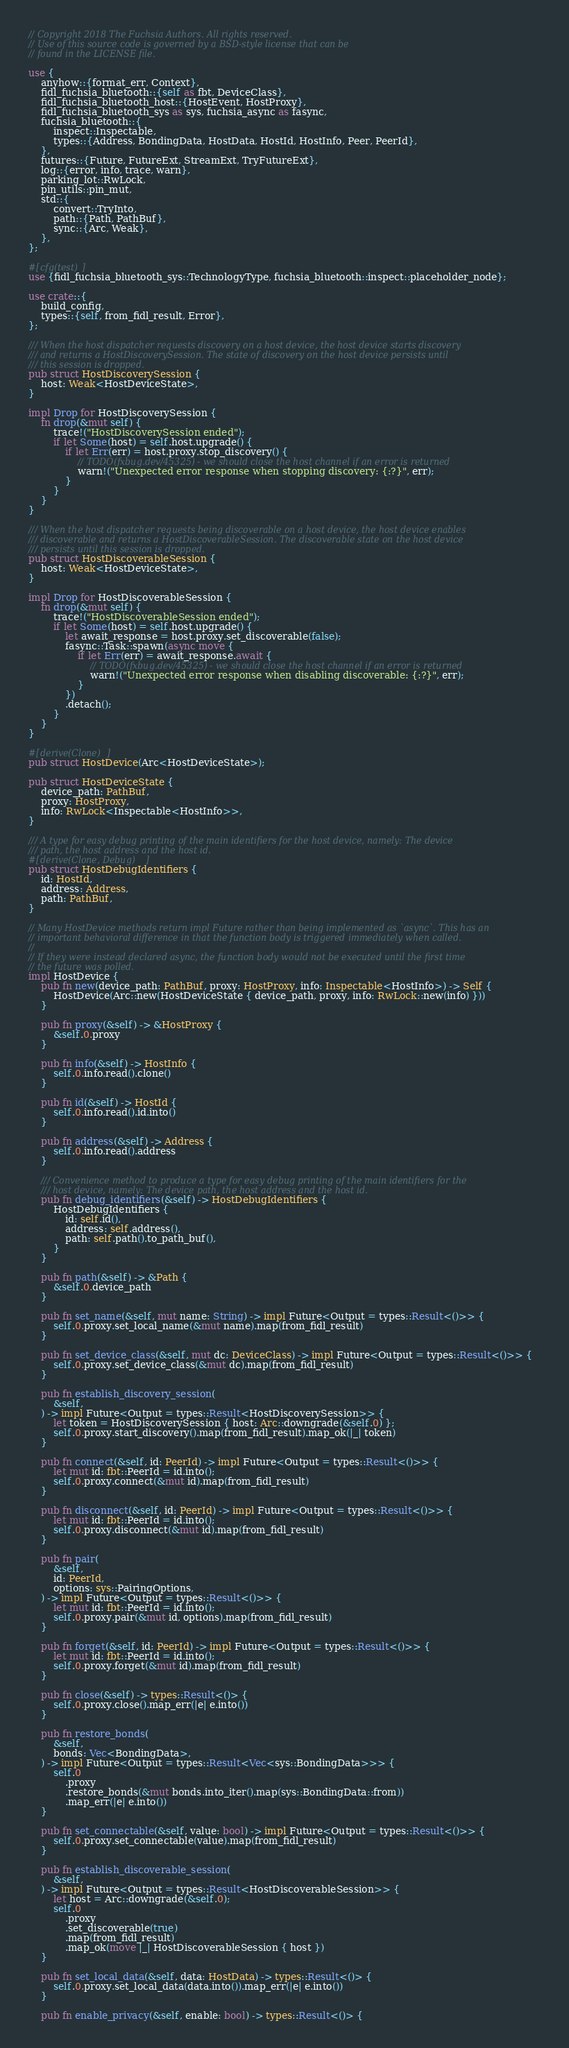Convert code to text. <code><loc_0><loc_0><loc_500><loc_500><_Rust_>// Copyright 2018 The Fuchsia Authors. All rights reserved.
// Use of this source code is governed by a BSD-style license that can be
// found in the LICENSE file.

use {
    anyhow::{format_err, Context},
    fidl_fuchsia_bluetooth::{self as fbt, DeviceClass},
    fidl_fuchsia_bluetooth_host::{HostEvent, HostProxy},
    fidl_fuchsia_bluetooth_sys as sys, fuchsia_async as fasync,
    fuchsia_bluetooth::{
        inspect::Inspectable,
        types::{Address, BondingData, HostData, HostId, HostInfo, Peer, PeerId},
    },
    futures::{Future, FutureExt, StreamExt, TryFutureExt},
    log::{error, info, trace, warn},
    parking_lot::RwLock,
    pin_utils::pin_mut,
    std::{
        convert::TryInto,
        path::{Path, PathBuf},
        sync::{Arc, Weak},
    },
};

#[cfg(test)]
use {fidl_fuchsia_bluetooth_sys::TechnologyType, fuchsia_bluetooth::inspect::placeholder_node};

use crate::{
    build_config,
    types::{self, from_fidl_result, Error},
};

/// When the host dispatcher requests discovery on a host device, the host device starts discovery
/// and returns a HostDiscoverySession. The state of discovery on the host device persists until
/// this session is dropped.
pub struct HostDiscoverySession {
    host: Weak<HostDeviceState>,
}

impl Drop for HostDiscoverySession {
    fn drop(&mut self) {
        trace!("HostDiscoverySession ended");
        if let Some(host) = self.host.upgrade() {
            if let Err(err) = host.proxy.stop_discovery() {
                // TODO(fxbug.dev/45325) - we should close the host channel if an error is returned
                warn!("Unexpected error response when stopping discovery: {:?}", err);
            }
        }
    }
}

/// When the host dispatcher requests being discoverable on a host device, the host device enables
/// discoverable and returns a HostDiscoverableSession. The discoverable state on the host device
/// persists until this session is dropped.
pub struct HostDiscoverableSession {
    host: Weak<HostDeviceState>,
}

impl Drop for HostDiscoverableSession {
    fn drop(&mut self) {
        trace!("HostDiscoverableSession ended");
        if let Some(host) = self.host.upgrade() {
            let await_response = host.proxy.set_discoverable(false);
            fasync::Task::spawn(async move {
                if let Err(err) = await_response.await {
                    // TODO(fxbug.dev/45325) - we should close the host channel if an error is returned
                    warn!("Unexpected error response when disabling discoverable: {:?}", err);
                }
            })
            .detach();
        }
    }
}

#[derive(Clone)]
pub struct HostDevice(Arc<HostDeviceState>);

pub struct HostDeviceState {
    device_path: PathBuf,
    proxy: HostProxy,
    info: RwLock<Inspectable<HostInfo>>,
}

/// A type for easy debug printing of the main identifiers for the host device, namely: The device
/// path, the host address and the host id.
#[derive(Clone, Debug)]
pub struct HostDebugIdentifiers {
    id: HostId,
    address: Address,
    path: PathBuf,
}

// Many HostDevice methods return impl Future rather than being implemented as `async`. This has an
// important behavioral difference in that the function body is triggered immediately when called.
//
// If they were instead declared async, the function body would not be executed until the first time
// the future was polled.
impl HostDevice {
    pub fn new(device_path: PathBuf, proxy: HostProxy, info: Inspectable<HostInfo>) -> Self {
        HostDevice(Arc::new(HostDeviceState { device_path, proxy, info: RwLock::new(info) }))
    }

    pub fn proxy(&self) -> &HostProxy {
        &self.0.proxy
    }

    pub fn info(&self) -> HostInfo {
        self.0.info.read().clone()
    }

    pub fn id(&self) -> HostId {
        self.0.info.read().id.into()
    }

    pub fn address(&self) -> Address {
        self.0.info.read().address
    }

    /// Convenience method to produce a type for easy debug printing of the main identifiers for the
    /// host device, namely: The device path, the host address and the host id.
    pub fn debug_identifiers(&self) -> HostDebugIdentifiers {
        HostDebugIdentifiers {
            id: self.id(),
            address: self.address(),
            path: self.path().to_path_buf(),
        }
    }

    pub fn path(&self) -> &Path {
        &self.0.device_path
    }

    pub fn set_name(&self, mut name: String) -> impl Future<Output = types::Result<()>> {
        self.0.proxy.set_local_name(&mut name).map(from_fidl_result)
    }

    pub fn set_device_class(&self, mut dc: DeviceClass) -> impl Future<Output = types::Result<()>> {
        self.0.proxy.set_device_class(&mut dc).map(from_fidl_result)
    }

    pub fn establish_discovery_session(
        &self,
    ) -> impl Future<Output = types::Result<HostDiscoverySession>> {
        let token = HostDiscoverySession { host: Arc::downgrade(&self.0) };
        self.0.proxy.start_discovery().map(from_fidl_result).map_ok(|_| token)
    }

    pub fn connect(&self, id: PeerId) -> impl Future<Output = types::Result<()>> {
        let mut id: fbt::PeerId = id.into();
        self.0.proxy.connect(&mut id).map(from_fidl_result)
    }

    pub fn disconnect(&self, id: PeerId) -> impl Future<Output = types::Result<()>> {
        let mut id: fbt::PeerId = id.into();
        self.0.proxy.disconnect(&mut id).map(from_fidl_result)
    }

    pub fn pair(
        &self,
        id: PeerId,
        options: sys::PairingOptions,
    ) -> impl Future<Output = types::Result<()>> {
        let mut id: fbt::PeerId = id.into();
        self.0.proxy.pair(&mut id, options).map(from_fidl_result)
    }

    pub fn forget(&self, id: PeerId) -> impl Future<Output = types::Result<()>> {
        let mut id: fbt::PeerId = id.into();
        self.0.proxy.forget(&mut id).map(from_fidl_result)
    }

    pub fn close(&self) -> types::Result<()> {
        self.0.proxy.close().map_err(|e| e.into())
    }

    pub fn restore_bonds(
        &self,
        bonds: Vec<BondingData>,
    ) -> impl Future<Output = types::Result<Vec<sys::BondingData>>> {
        self.0
            .proxy
            .restore_bonds(&mut bonds.into_iter().map(sys::BondingData::from))
            .map_err(|e| e.into())
    }

    pub fn set_connectable(&self, value: bool) -> impl Future<Output = types::Result<()>> {
        self.0.proxy.set_connectable(value).map(from_fidl_result)
    }

    pub fn establish_discoverable_session(
        &self,
    ) -> impl Future<Output = types::Result<HostDiscoverableSession>> {
        let host = Arc::downgrade(&self.0);
        self.0
            .proxy
            .set_discoverable(true)
            .map(from_fidl_result)
            .map_ok(move |_| HostDiscoverableSession { host })
    }

    pub fn set_local_data(&self, data: HostData) -> types::Result<()> {
        self.0.proxy.set_local_data(data.into()).map_err(|e| e.into())
    }

    pub fn enable_privacy(&self, enable: bool) -> types::Result<()> {</code> 